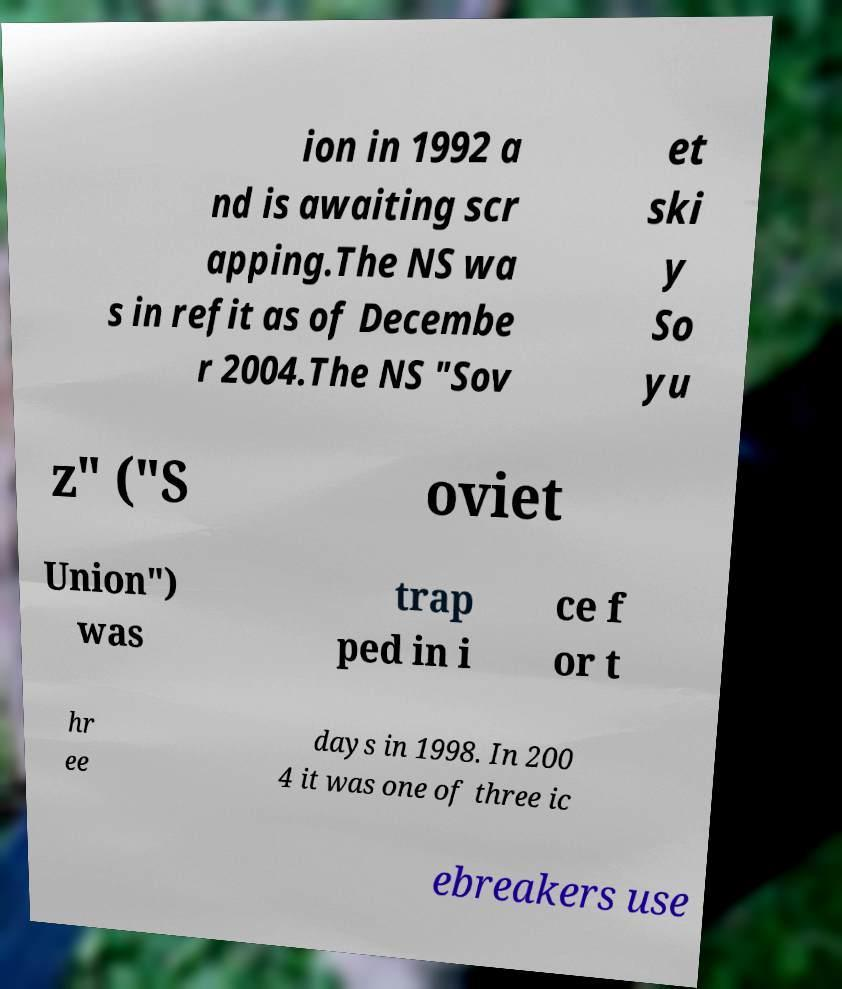Could you extract and type out the text from this image? ion in 1992 a nd is awaiting scr apping.The NS wa s in refit as of Decembe r 2004.The NS "Sov et ski y So yu z" ("S oviet Union") was trap ped in i ce f or t hr ee days in 1998. In 200 4 it was one of three ic ebreakers use 